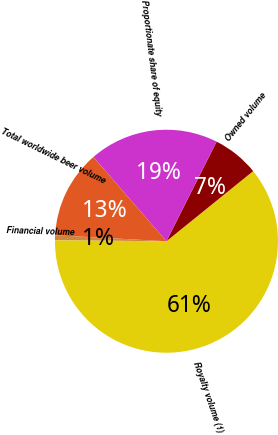Convert chart to OTSL. <chart><loc_0><loc_0><loc_500><loc_500><pie_chart><fcel>Financial volume<fcel>Royalty volume (1)<fcel>Owned volume<fcel>Proportionate share of equity<fcel>Total worldwide beer volume<nl><fcel>0.73%<fcel>60.96%<fcel>6.75%<fcel>18.8%<fcel>12.77%<nl></chart> 